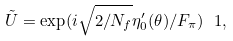<formula> <loc_0><loc_0><loc_500><loc_500>\tilde { U } = \exp ( i \sqrt { 2 / N _ { f } } \eta ^ { \prime } _ { 0 } ( \theta ) / F _ { \pi } ) \ 1 ,</formula> 